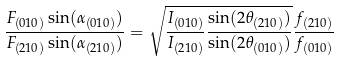Convert formula to latex. <formula><loc_0><loc_0><loc_500><loc_500>\frac { F _ { ( 0 1 0 ) } \sin ( \alpha _ { ( 0 1 0 ) } ) } { F _ { ( 2 1 0 ) } \sin ( \alpha _ { ( 2 1 0 ) } ) } = \sqrt { \frac { I _ { ( 0 1 0 ) } } { I _ { ( 2 1 0 ) } } \frac { \sin ( 2 \theta _ { ( 2 1 0 ) } ) } { \sin ( 2 \theta _ { ( 0 1 0 ) } ) } } \frac { f _ { ( 2 1 0 ) } } { f _ { ( 0 1 0 ) } }</formula> 